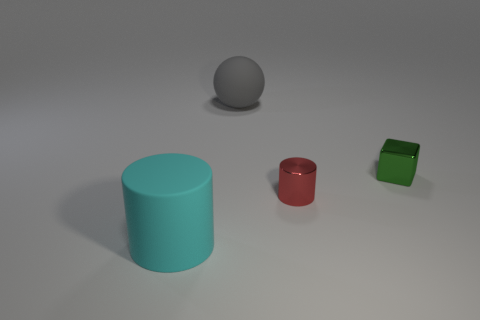How big is the thing that is to the left of the green block and behind the red cylinder?
Offer a very short reply. Large. Are there fewer large things on the right side of the big gray object than red matte balls?
Provide a short and direct response. No. Is the gray thing made of the same material as the red object?
Provide a short and direct response. No. What number of objects are tiny green cubes or red metal objects?
Your answer should be very brief. 2. What number of tiny red cylinders have the same material as the cyan cylinder?
Give a very brief answer. 0. There is another metallic thing that is the same shape as the large cyan thing; what is its size?
Provide a short and direct response. Small. There is a small shiny block; are there any small red things left of it?
Keep it short and to the point. Yes. What is the red cylinder made of?
Give a very brief answer. Metal. Do the sphere that is behind the large cylinder and the small metallic cylinder have the same color?
Keep it short and to the point. No. Is there anything else that has the same shape as the small red shiny object?
Offer a very short reply. Yes. 